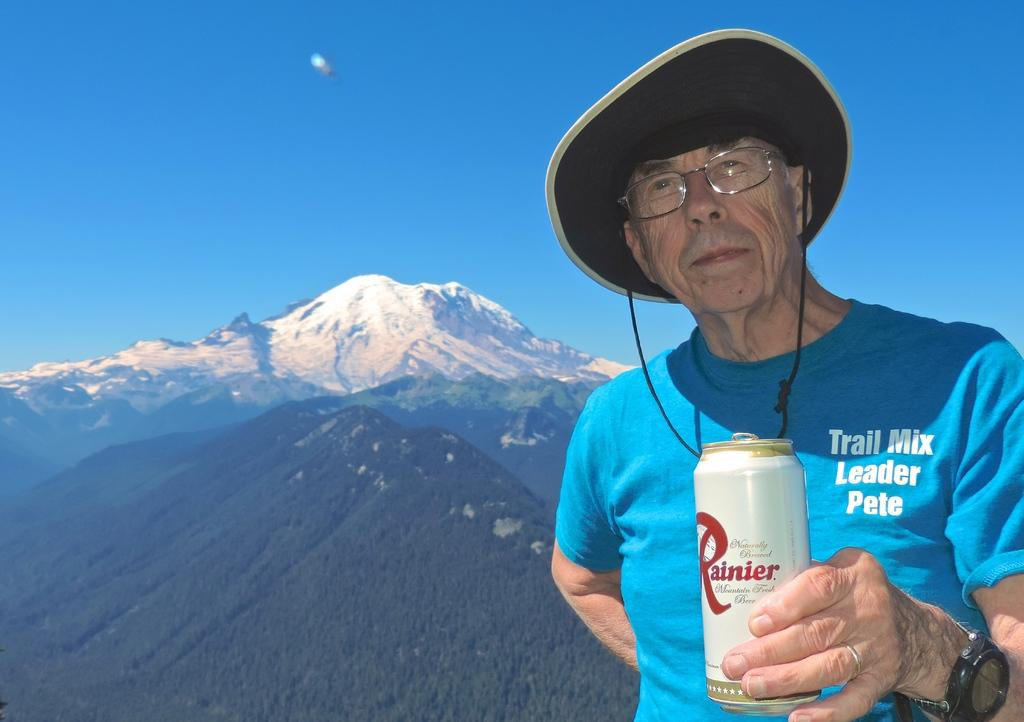What is the main subject in the foreground of the picture? There is a person in the foreground of the picture. What accessories is the person wearing? The person is wearing a cap and a watch. What object is the person holding in the image? The person is holding a tin. What can be seen in the background of the image? There are mountains covered with snow and trees in the background of the image. How would you describe the weather in the image? The sky is sunny in the image. What type of flowers can be seen growing around the cake in the image? There is no cake or flowers present in the image; it features a person holding a tin in the foreground and mountains covered with snow in the background. 